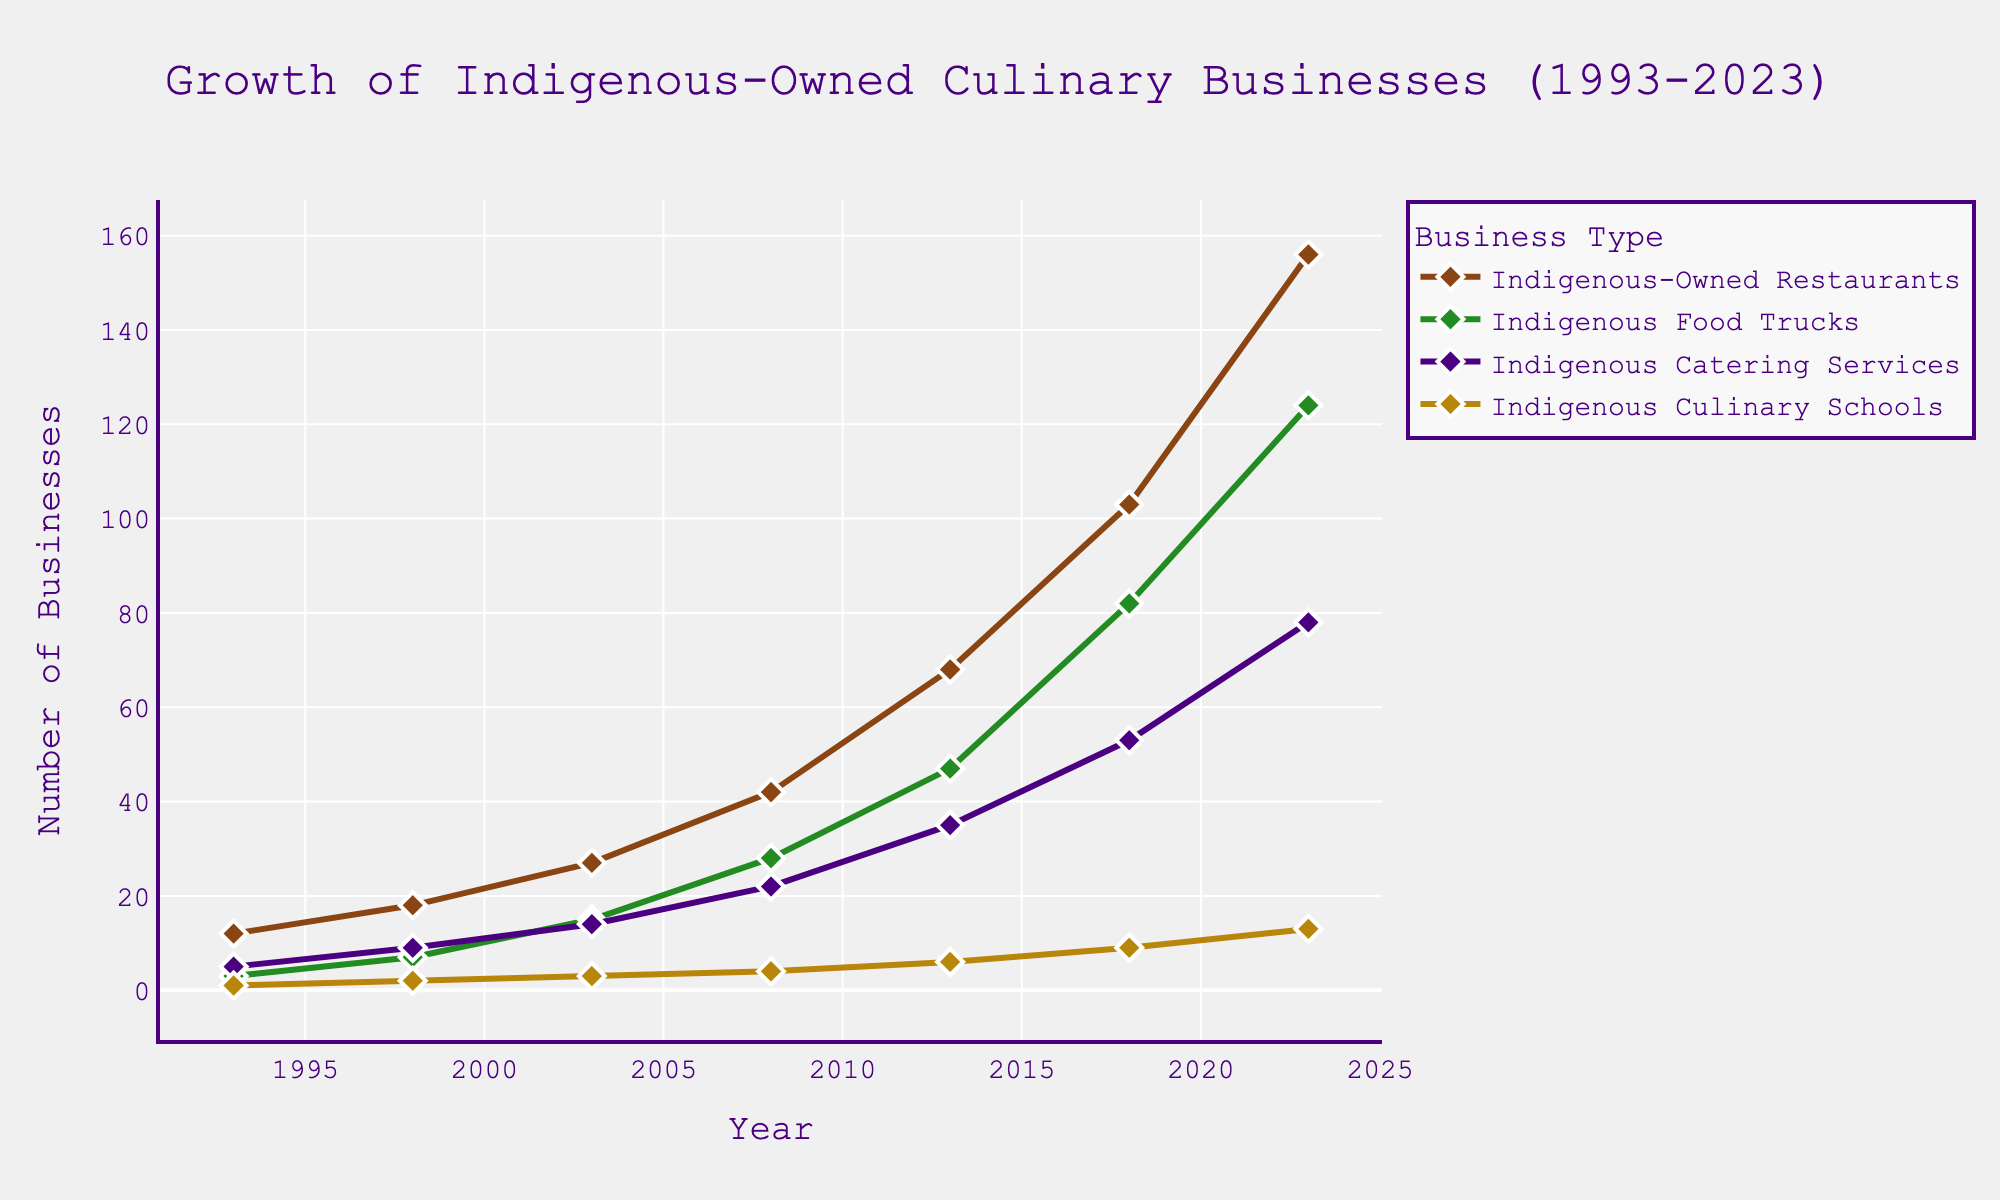What is the general trend of indigenous-owned restaurants over the past 30 years? The number of indigenous-owned restaurants has shown a steady increase from 12 in 1993 to 156 in 2023.
Answer: Steady increase In what year did the number of indigenous catering services reach 35? By examining the trend line for indigenous catering services, it reached 35 in the year 2013.
Answer: 2013 Which type of business experienced the steepest growth between 2018 and 2023? Comparing the slopes of the lines for each business type between 2018 and 2023, indigenous-owned restaurants had the steepest growth, increasing from 103 to 156.
Answer: Indigenous-Owned Restaurants What was the total number of indigenous culinary businesses in 2008? Summing up the values for 2008: Restaurants (42) + Food Trucks (28) + Catering Services (22) + Culinary Schools (4) = 96.
Answer: 96 How many more indigenous food trucks were there in 2023 compared to 2013? Subtracting the number of indigenous food trucks in 2013 (47) from that in 2023 (124) gives us the difference: 124 - 47 = 77.
Answer: 77 Which business type had the least number of establishments in 2023? By looking at the end points of the lines in 2023, indigenous culinary schools had the least with 13.
Answer: Indigenous Culinary Schools What is the average number of indigenous-owned restaurants between 1993 and 2023? Adding the values: 12 + 18 + 27 + 42 + 68 + 103 + 156 = 426. Dividing by the number of years (7) gives: 426 / 7 = 60.85.
Answer: 60.85 Did the number of indigenous catering services ever surpass the number of indigenous food trucks? By comparing the two lines throughout the years, the number of indigenous catering services never surpasses the number of indigenous food trucks at any point.
Answer: No What is the difference in the number of indigenous culinary schools between 2003 and 2023? Subtracting the number of indigenous culinary schools in 2003 (3) from that in 2023 (13) gives: 13 - 3 = 10.
Answer: 10 Which year saw the largest single-year increase in indigenous-owned restaurants? By examining the line for indigenous-owned restaurants, the largest increase appears between 2013 (68) and 2018 (103), with a difference of 35.
Answer: 2013 to 2018 